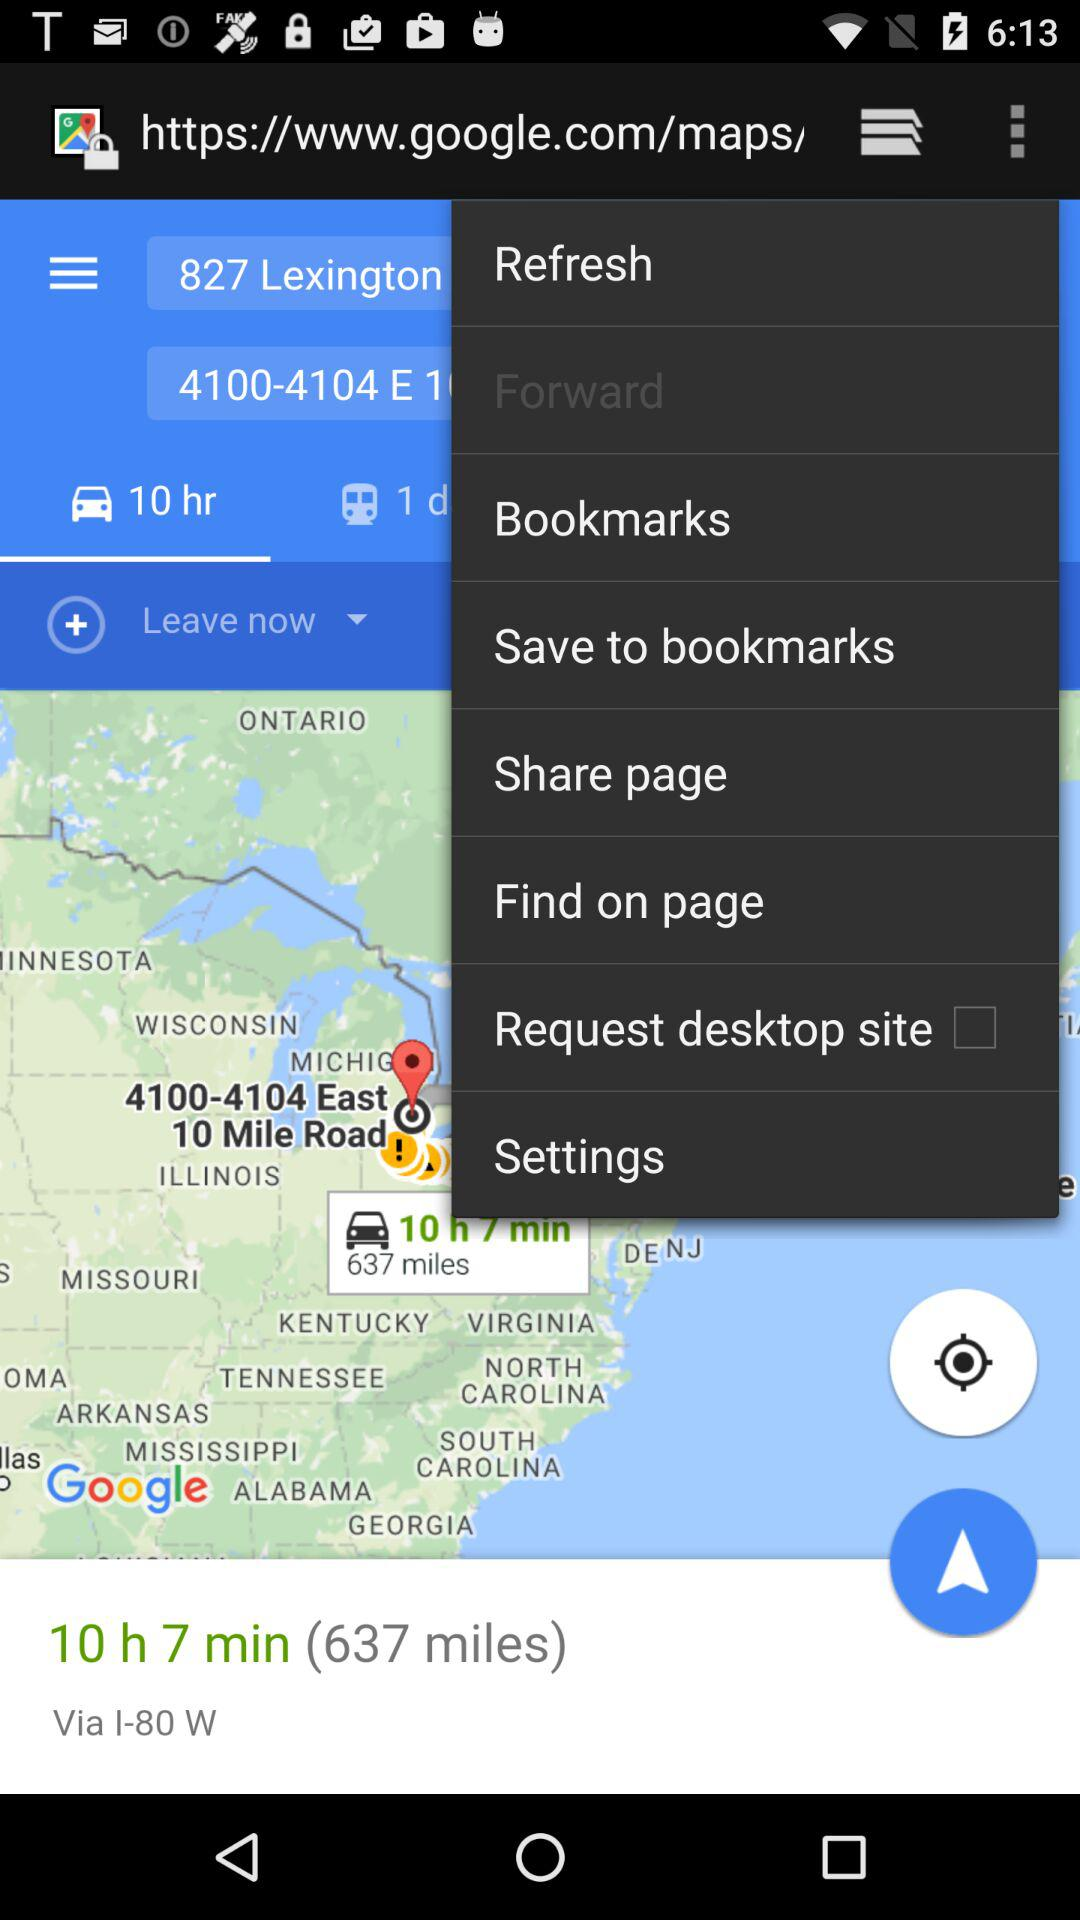What driving mode is selected?
When the provided information is insufficient, respond with <no answer>. <no answer> 